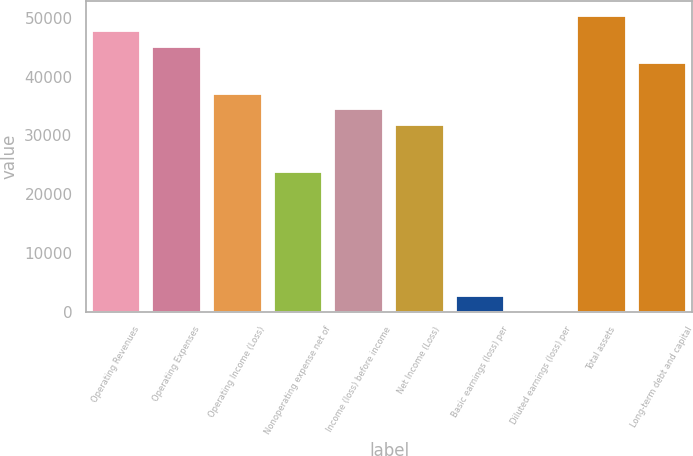Convert chart. <chart><loc_0><loc_0><loc_500><loc_500><bar_chart><fcel>Operating Revenues<fcel>Operating Expenses<fcel>Operating Income (Loss)<fcel>Nonoperating expense net of<fcel>Income (loss) before income<fcel>Net Income (Loss)<fcel>Basic earnings (loss) per<fcel>Diluted earnings (loss) per<fcel>Total assets<fcel>Long-term debt and capital<nl><fcel>47699<fcel>45049.3<fcel>37100<fcel>23851.2<fcel>34450.2<fcel>31800.5<fcel>2653.12<fcel>3.36<fcel>50348.8<fcel>42399.5<nl></chart> 